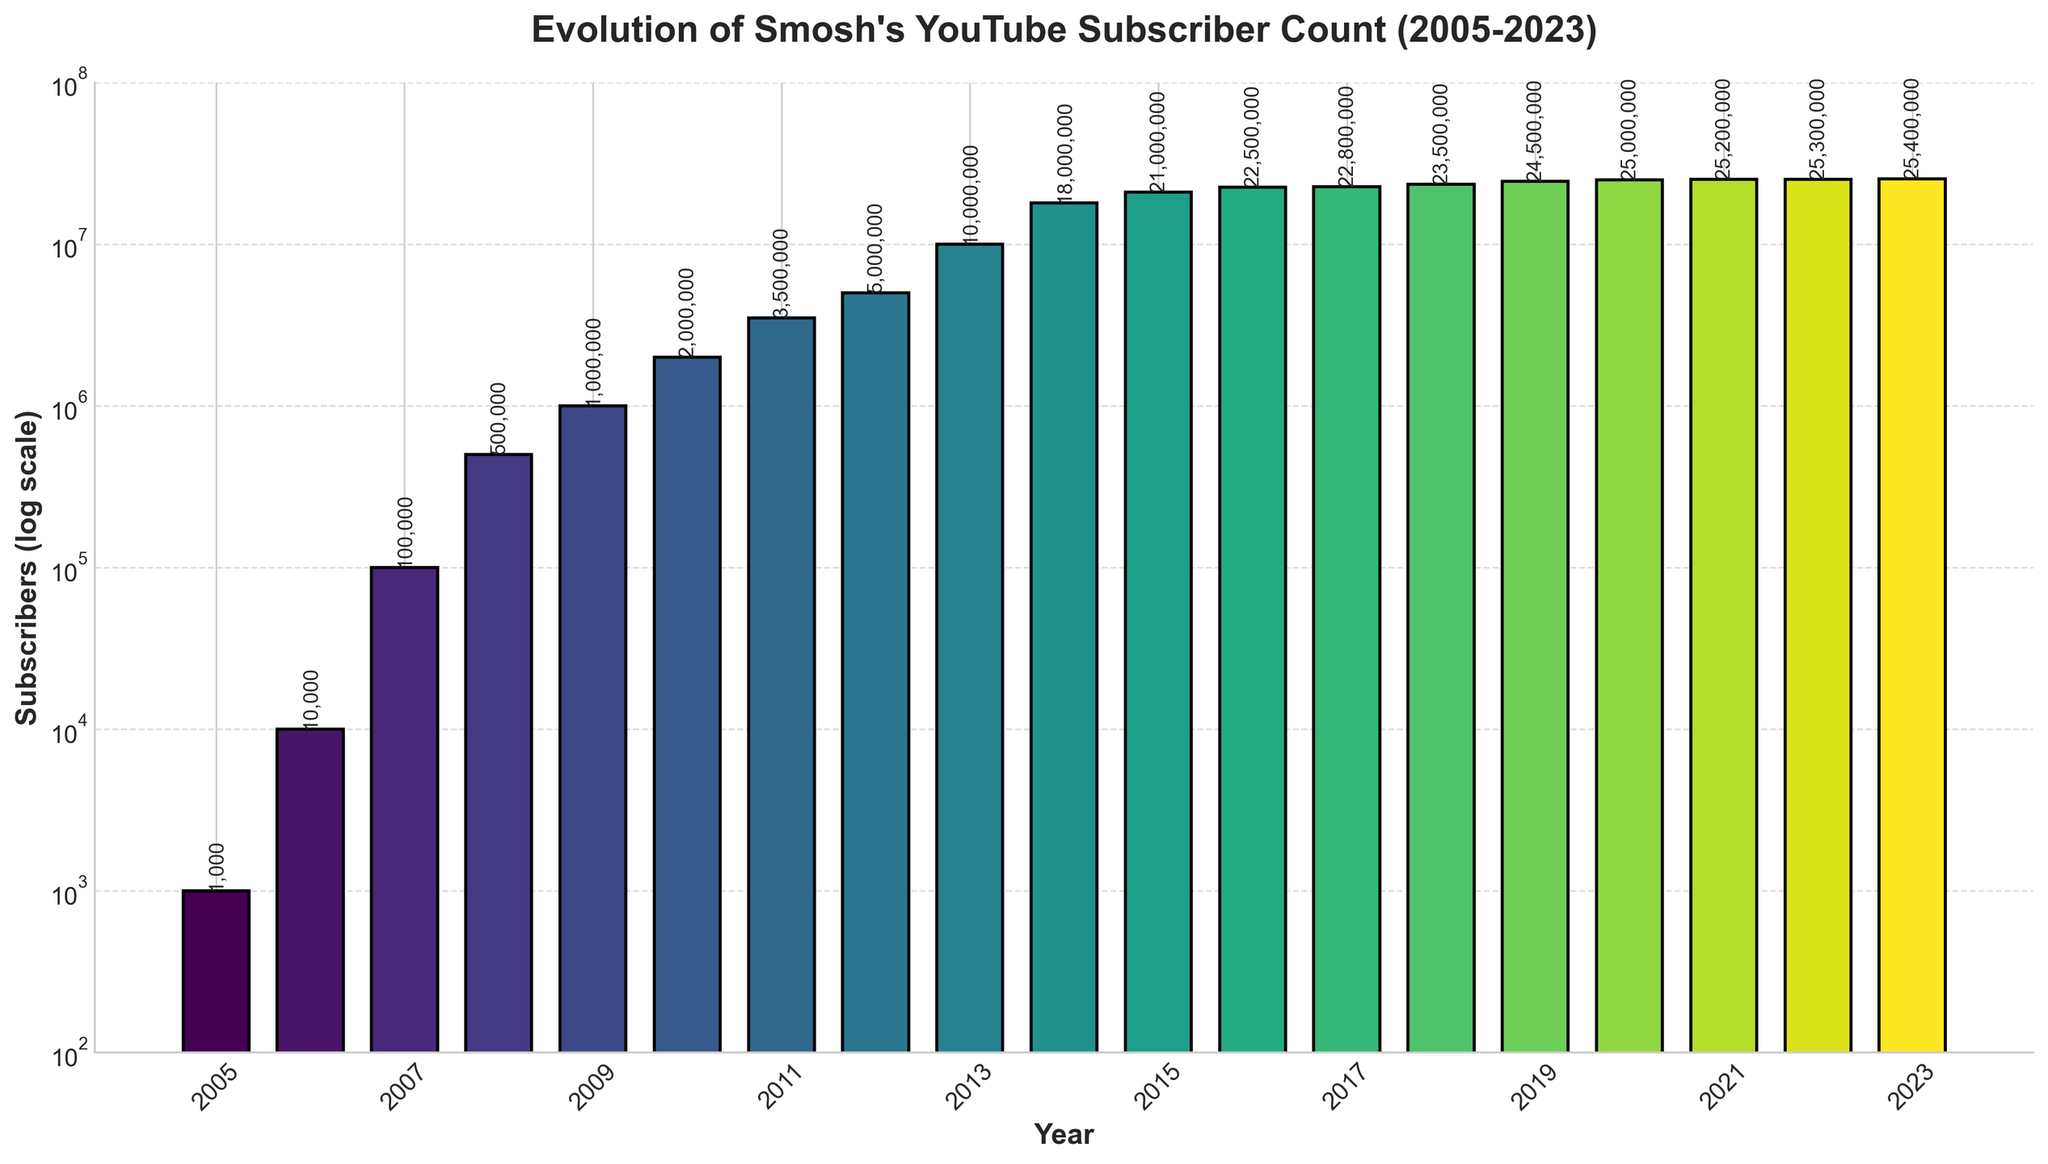what is the total number of subscribers gained from 2005 to 2023? Sum all the subscriber counts from each year: 1000 + 10000 + 100000 + 500000 + 1000000 + 2000000 + 3500000 + 5000000 + 10000000 + 18000000 + 21000000 + 22500000 + 22800000 + 23500000 + 24500000 + 25000000 + 25200000 + 25300000 + 25400000 = 287320000
Answer: 287320000 which year saw the highest increase in subscribers compared to the previous year? To find the highest increase, calculate the difference in subscribers for each consecutive year and identify the maximum change. This is done by comparing each year's subscriber count with the previous year's. 2014 to 2013 has the highest increase: 18000000 - 10000000 = 8000000
Answer: 2014 which years have subscriber counts greater than 20000000? Examine the subscriber counts for each year and select those greater than 20000000: 2015 (21000000), 2016 (22500000), 2017 (22800000), 2018 (23500000), 2019 (24500000), 2020 (25000000), 2021 (25200000), 2022 (25300000), 2023 (25400000)
Answer: 2015, 2016, 2017, 2018, 2019, 2020, 2021, 2022, 2023 how many years did it take for Smosh to reach 10 million subscribers? Determine the number of years between 2005 (the start year) and 2013 (when they hit 10 million): 2013 - 2005 = 8 years
Answer: 8 years what is the average number of subscribers from 2010 to 2015? Add the subscriber counts from 2010 to 2015 and divide by the number of years: (2000000 + 3500000 + 5000000 + 10000000 + 18000000 + 21000000)/6 = 99,166,666/6 = 16527777.66
Answer: 16527777.66 how many years did Smosh's subscribers grow continuously without decline? Examine the subscriber counts for consecutive years and count the years where there is continuous growth. From 2005 to 2023, all years show continuous growth, so it spans the entire period: 2023 - 2005 = 18 years
Answer: 18 years what is the median subscriber count for the entire period from 2005 to 2023? Arrange all the subscriber counts in ascending order and find the middle value. There are 19 data points, so the median will be the 10th value: 2005 (1000), 2006 (10000), 2007 (100000), 2008 (500000), 2009 (1000000), 2010 (2000000), 2011 (3500000), 2012 (5000000), 2013 (10000000), 2014 (18000000), 2015 (21000000), 2016 (22500000), 2017 (22800000), 2018 (23500000), 2019 (24500000), 2020 (25000000), 2021 (25200000), 2022 (25300000), 2023 (25400000); the 10th value is 18000000
Answer: 18000000 compared to 2005, by how much did Smosh's subscriber count increase in 2012? Find the difference in subscriber counts between 2012 and 2005: 5000000 - 1000 = 4999000
Answer: 4999000 